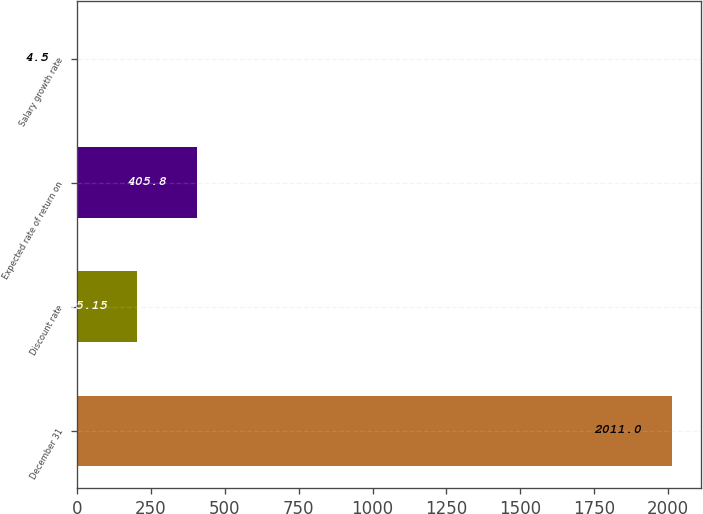<chart> <loc_0><loc_0><loc_500><loc_500><bar_chart><fcel>December 31<fcel>Discount rate<fcel>Expected rate of return on<fcel>Salary growth rate<nl><fcel>2011<fcel>205.15<fcel>405.8<fcel>4.5<nl></chart> 